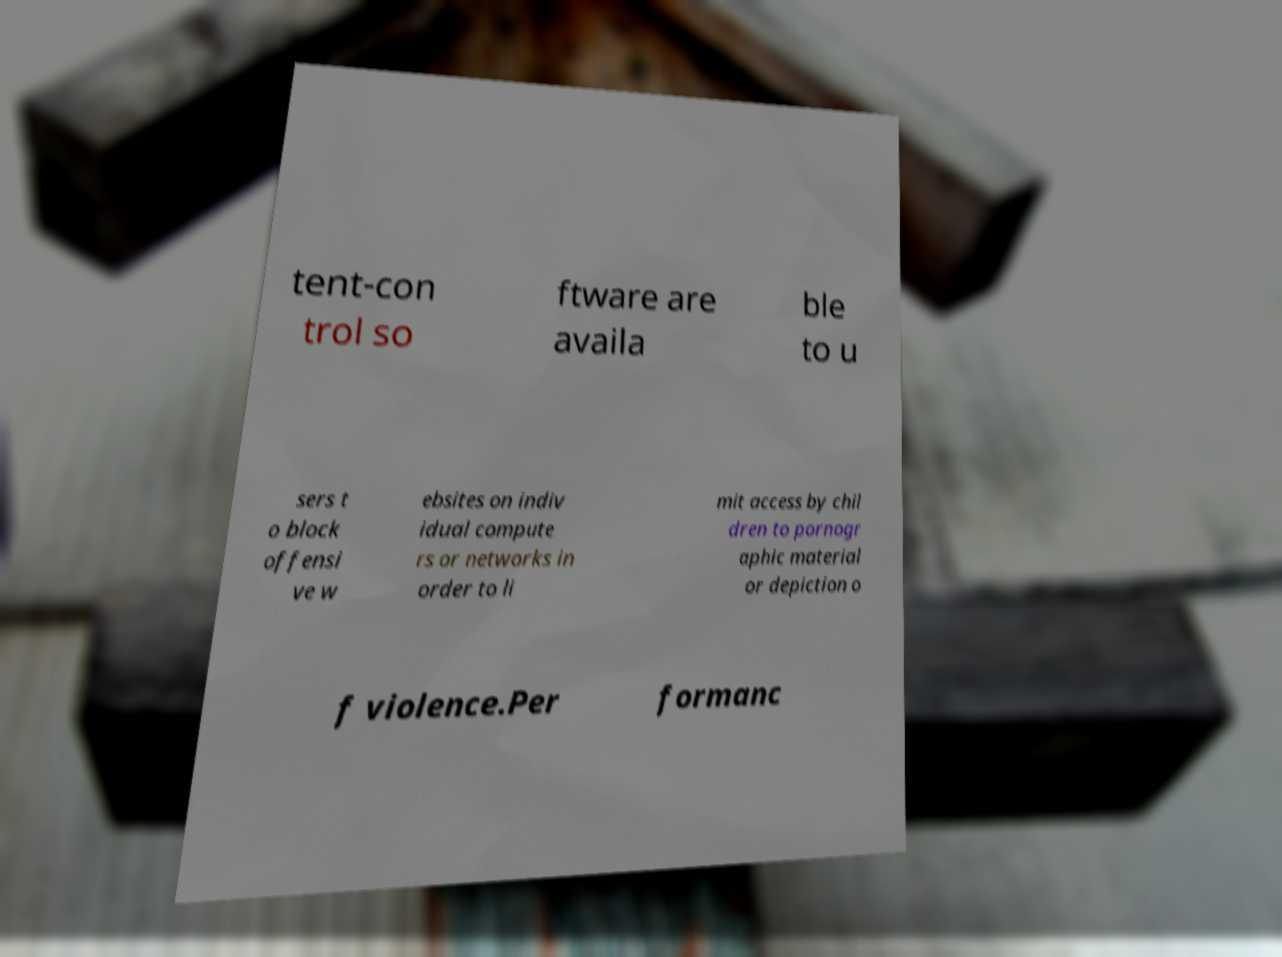What messages or text are displayed in this image? I need them in a readable, typed format. tent-con trol so ftware are availa ble to u sers t o block offensi ve w ebsites on indiv idual compute rs or networks in order to li mit access by chil dren to pornogr aphic material or depiction o f violence.Per formanc 